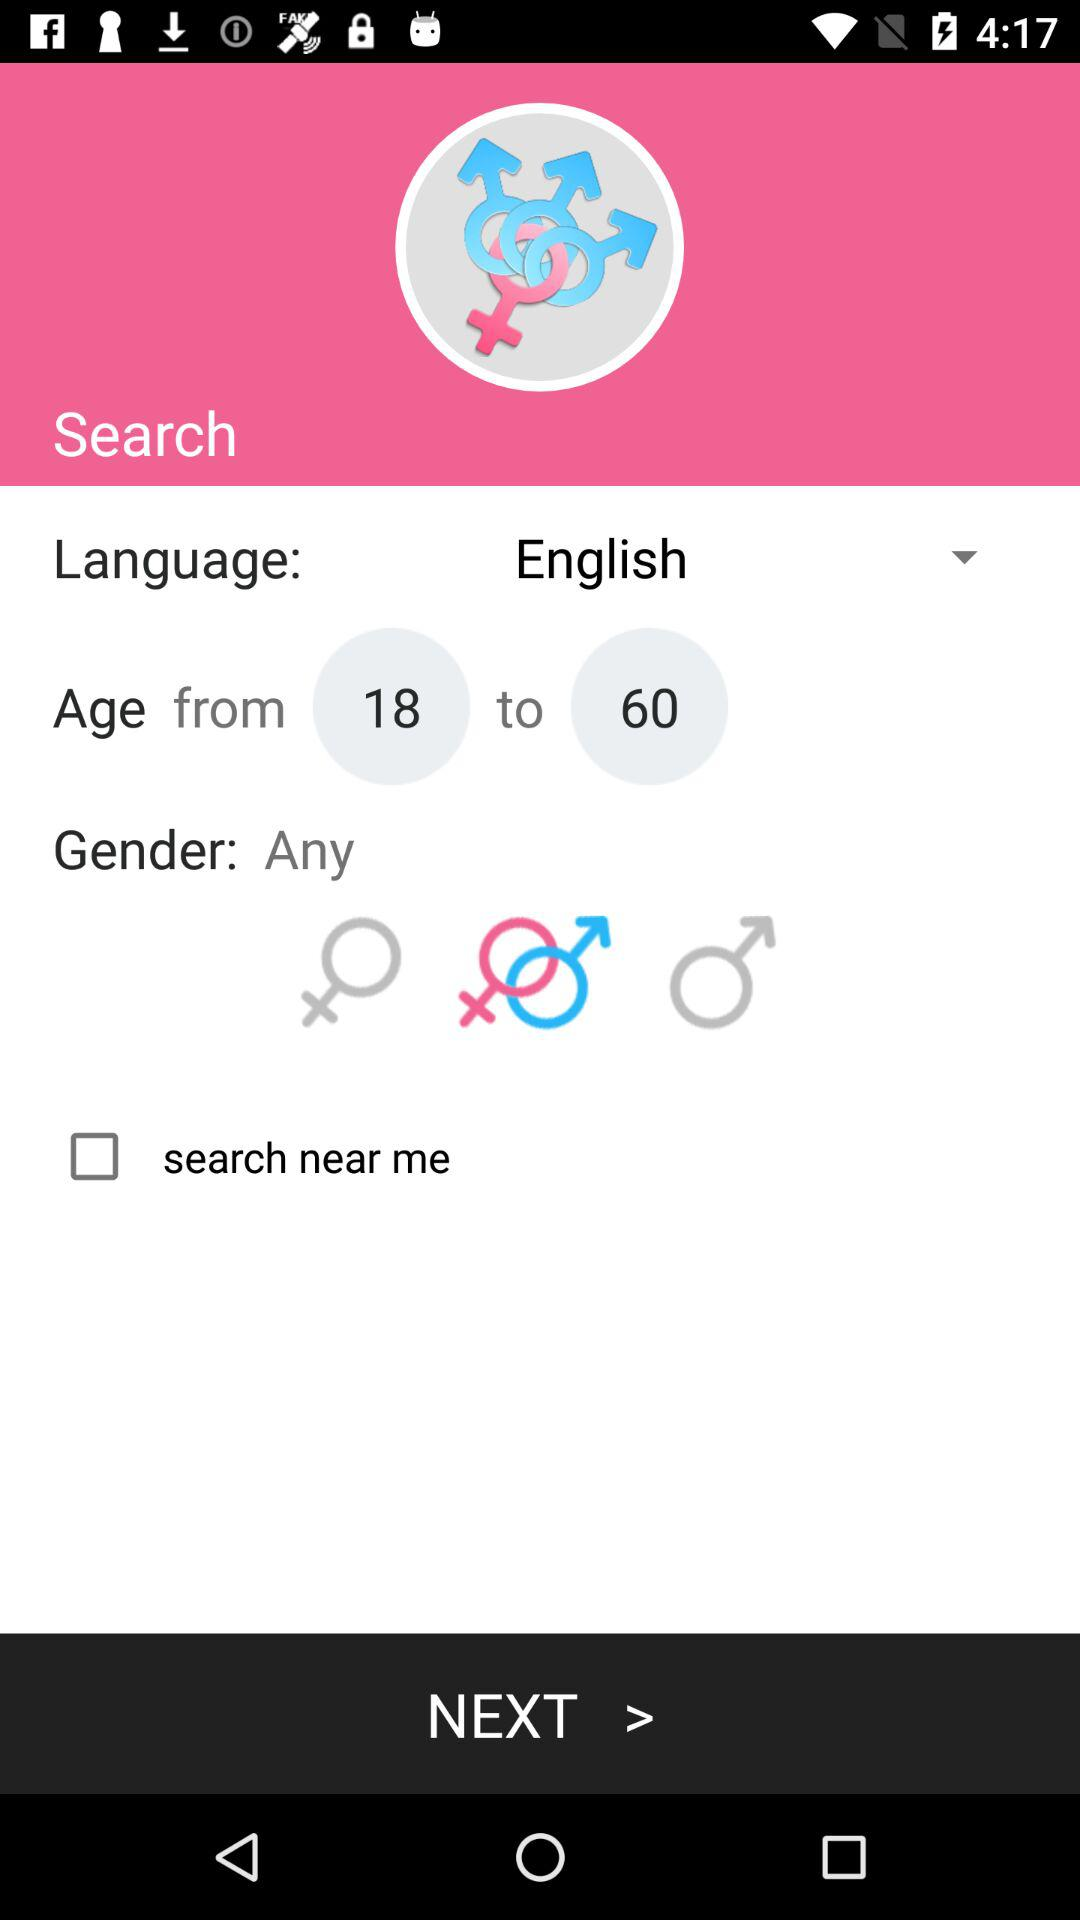What is the status of the "near me search"? The status is "off". 